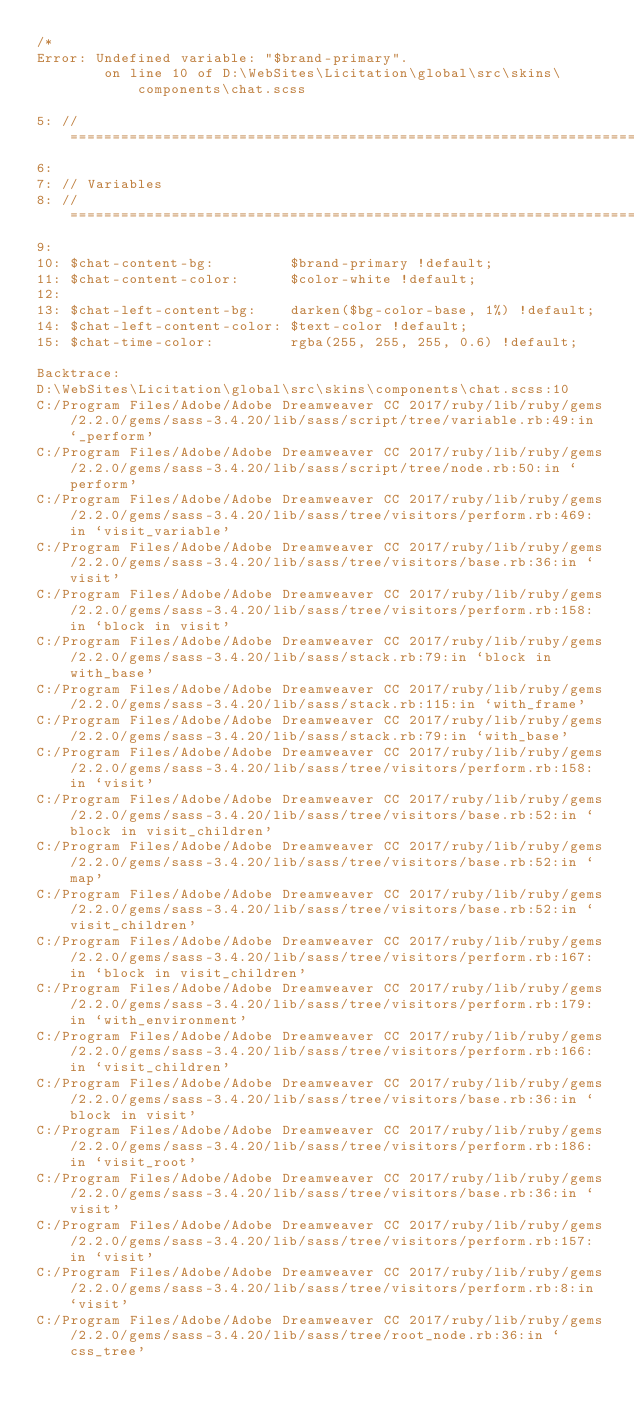Convert code to text. <code><loc_0><loc_0><loc_500><loc_500><_CSS_>/*
Error: Undefined variable: "$brand-primary".
        on line 10 of D:\WebSites\Licitation\global\src\skins\components\chat.scss

5: // ========================================================================
6: 
7: // Variables
8: // ========================================================================
9: 
10: $chat-content-bg:         $brand-primary !default;
11: $chat-content-color:      $color-white !default;
12: 
13: $chat-left-content-bg:    darken($bg-color-base, 1%) !default;
14: $chat-left-content-color: $text-color !default;
15: $chat-time-color:         rgba(255, 255, 255, 0.6) !default;

Backtrace:
D:\WebSites\Licitation\global\src\skins\components\chat.scss:10
C:/Program Files/Adobe/Adobe Dreamweaver CC 2017/ruby/lib/ruby/gems/2.2.0/gems/sass-3.4.20/lib/sass/script/tree/variable.rb:49:in `_perform'
C:/Program Files/Adobe/Adobe Dreamweaver CC 2017/ruby/lib/ruby/gems/2.2.0/gems/sass-3.4.20/lib/sass/script/tree/node.rb:50:in `perform'
C:/Program Files/Adobe/Adobe Dreamweaver CC 2017/ruby/lib/ruby/gems/2.2.0/gems/sass-3.4.20/lib/sass/tree/visitors/perform.rb:469:in `visit_variable'
C:/Program Files/Adobe/Adobe Dreamweaver CC 2017/ruby/lib/ruby/gems/2.2.0/gems/sass-3.4.20/lib/sass/tree/visitors/base.rb:36:in `visit'
C:/Program Files/Adobe/Adobe Dreamweaver CC 2017/ruby/lib/ruby/gems/2.2.0/gems/sass-3.4.20/lib/sass/tree/visitors/perform.rb:158:in `block in visit'
C:/Program Files/Adobe/Adobe Dreamweaver CC 2017/ruby/lib/ruby/gems/2.2.0/gems/sass-3.4.20/lib/sass/stack.rb:79:in `block in with_base'
C:/Program Files/Adobe/Adobe Dreamweaver CC 2017/ruby/lib/ruby/gems/2.2.0/gems/sass-3.4.20/lib/sass/stack.rb:115:in `with_frame'
C:/Program Files/Adobe/Adobe Dreamweaver CC 2017/ruby/lib/ruby/gems/2.2.0/gems/sass-3.4.20/lib/sass/stack.rb:79:in `with_base'
C:/Program Files/Adobe/Adobe Dreamweaver CC 2017/ruby/lib/ruby/gems/2.2.0/gems/sass-3.4.20/lib/sass/tree/visitors/perform.rb:158:in `visit'
C:/Program Files/Adobe/Adobe Dreamweaver CC 2017/ruby/lib/ruby/gems/2.2.0/gems/sass-3.4.20/lib/sass/tree/visitors/base.rb:52:in `block in visit_children'
C:/Program Files/Adobe/Adobe Dreamweaver CC 2017/ruby/lib/ruby/gems/2.2.0/gems/sass-3.4.20/lib/sass/tree/visitors/base.rb:52:in `map'
C:/Program Files/Adobe/Adobe Dreamweaver CC 2017/ruby/lib/ruby/gems/2.2.0/gems/sass-3.4.20/lib/sass/tree/visitors/base.rb:52:in `visit_children'
C:/Program Files/Adobe/Adobe Dreamweaver CC 2017/ruby/lib/ruby/gems/2.2.0/gems/sass-3.4.20/lib/sass/tree/visitors/perform.rb:167:in `block in visit_children'
C:/Program Files/Adobe/Adobe Dreamweaver CC 2017/ruby/lib/ruby/gems/2.2.0/gems/sass-3.4.20/lib/sass/tree/visitors/perform.rb:179:in `with_environment'
C:/Program Files/Adobe/Adobe Dreamweaver CC 2017/ruby/lib/ruby/gems/2.2.0/gems/sass-3.4.20/lib/sass/tree/visitors/perform.rb:166:in `visit_children'
C:/Program Files/Adobe/Adobe Dreamweaver CC 2017/ruby/lib/ruby/gems/2.2.0/gems/sass-3.4.20/lib/sass/tree/visitors/base.rb:36:in `block in visit'
C:/Program Files/Adobe/Adobe Dreamweaver CC 2017/ruby/lib/ruby/gems/2.2.0/gems/sass-3.4.20/lib/sass/tree/visitors/perform.rb:186:in `visit_root'
C:/Program Files/Adobe/Adobe Dreamweaver CC 2017/ruby/lib/ruby/gems/2.2.0/gems/sass-3.4.20/lib/sass/tree/visitors/base.rb:36:in `visit'
C:/Program Files/Adobe/Adobe Dreamweaver CC 2017/ruby/lib/ruby/gems/2.2.0/gems/sass-3.4.20/lib/sass/tree/visitors/perform.rb:157:in `visit'
C:/Program Files/Adobe/Adobe Dreamweaver CC 2017/ruby/lib/ruby/gems/2.2.0/gems/sass-3.4.20/lib/sass/tree/visitors/perform.rb:8:in `visit'
C:/Program Files/Adobe/Adobe Dreamweaver CC 2017/ruby/lib/ruby/gems/2.2.0/gems/sass-3.4.20/lib/sass/tree/root_node.rb:36:in `css_tree'</code> 